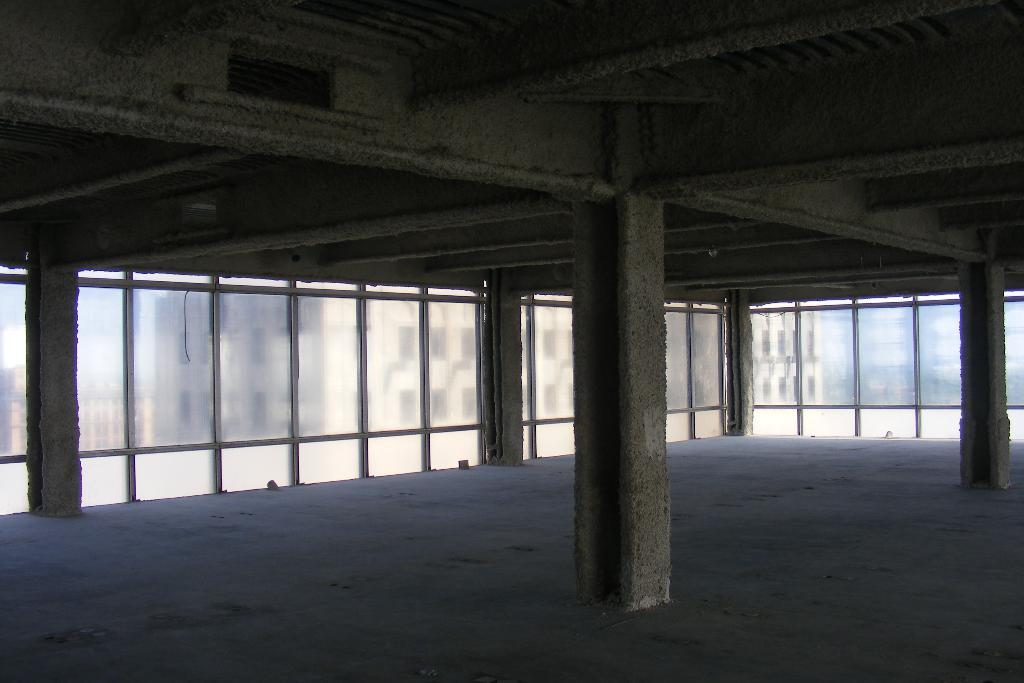Where was the image taken from? The image was taken from inside a building. What architectural features can be seen in the image? There are pillars in the image. What type of wall is visible in the background of the image? There is a glass wall in the background of the image. What part of the building's interior is visible at the top of the image? The ceiling is visible at the top of the image. What type of oil can be seen dripping from the pillars in the image? There is no oil present in the image, and the pillars are not dripping anything. What type of button is visible on the glass wall in the image? There are no buttons visible on the glass wall in the image. 